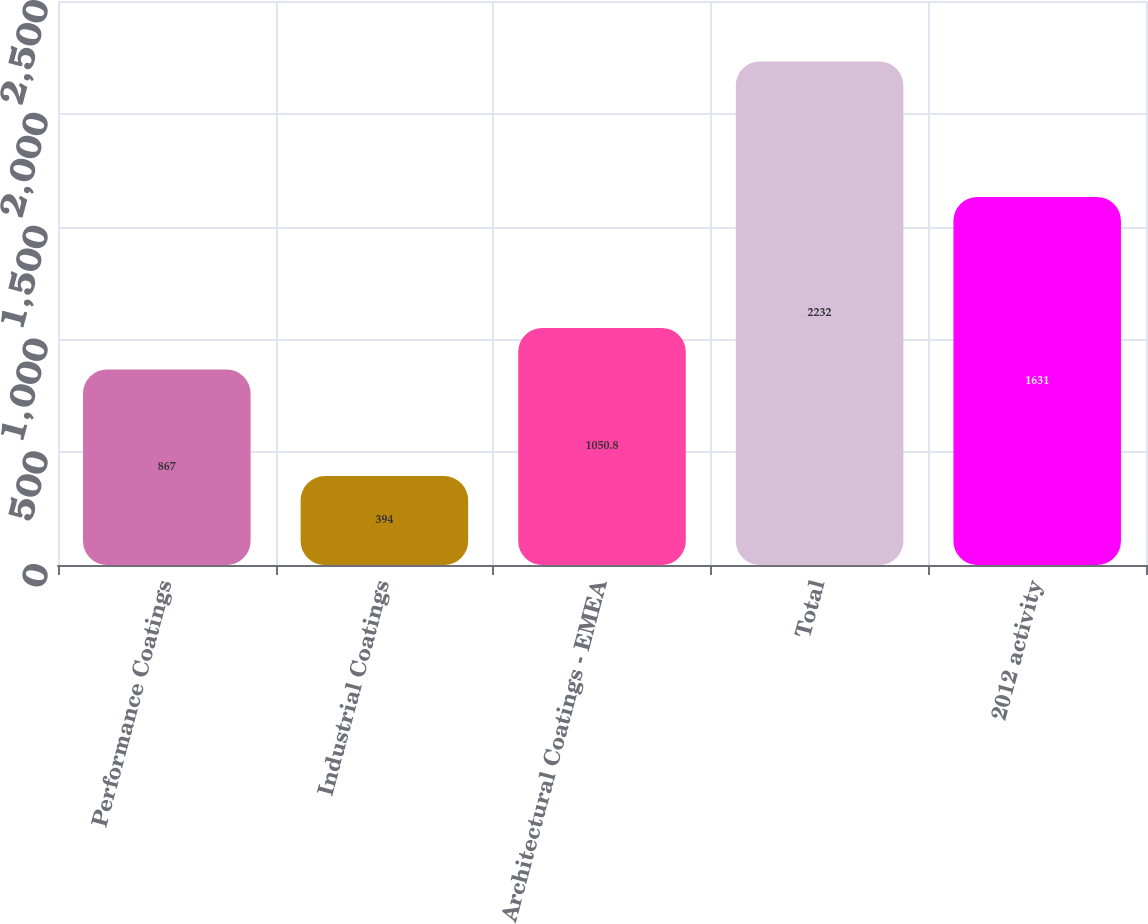<chart> <loc_0><loc_0><loc_500><loc_500><bar_chart><fcel>Performance Coatings<fcel>Industrial Coatings<fcel>Architectural Coatings - EMEA<fcel>Total<fcel>2012 activity<nl><fcel>867<fcel>394<fcel>1050.8<fcel>2232<fcel>1631<nl></chart> 